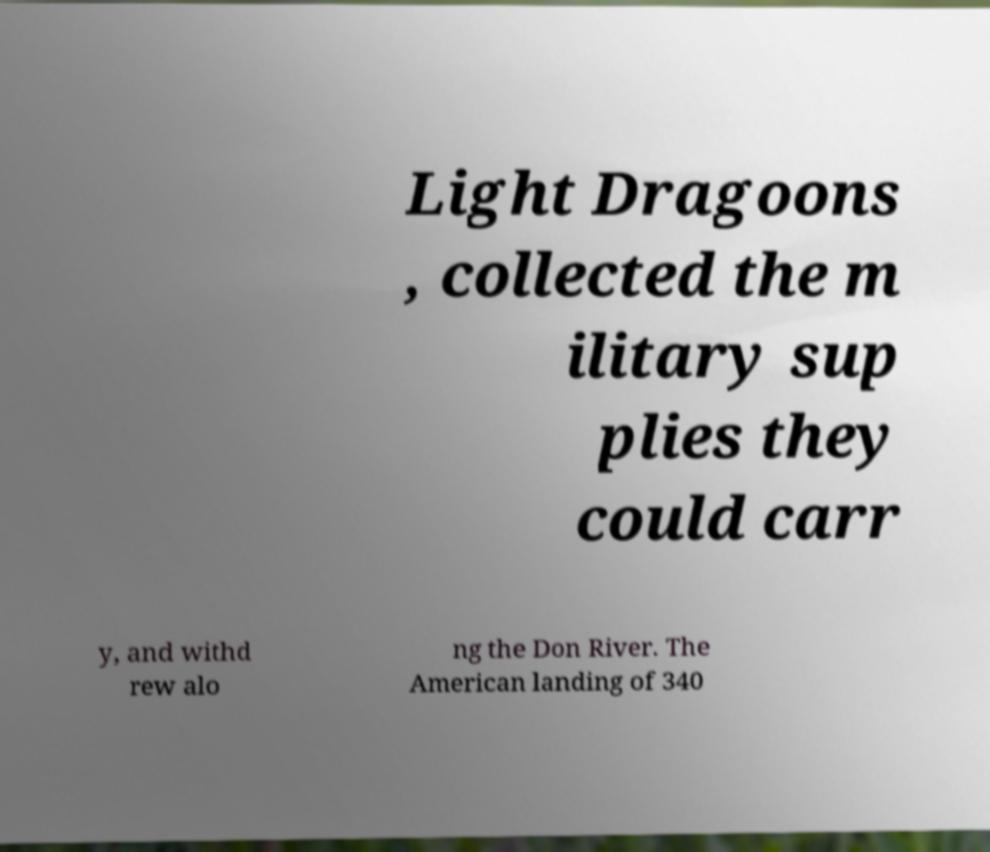Please read and relay the text visible in this image. What does it say? Light Dragoons , collected the m ilitary sup plies they could carr y, and withd rew alo ng the Don River. The American landing of 340 